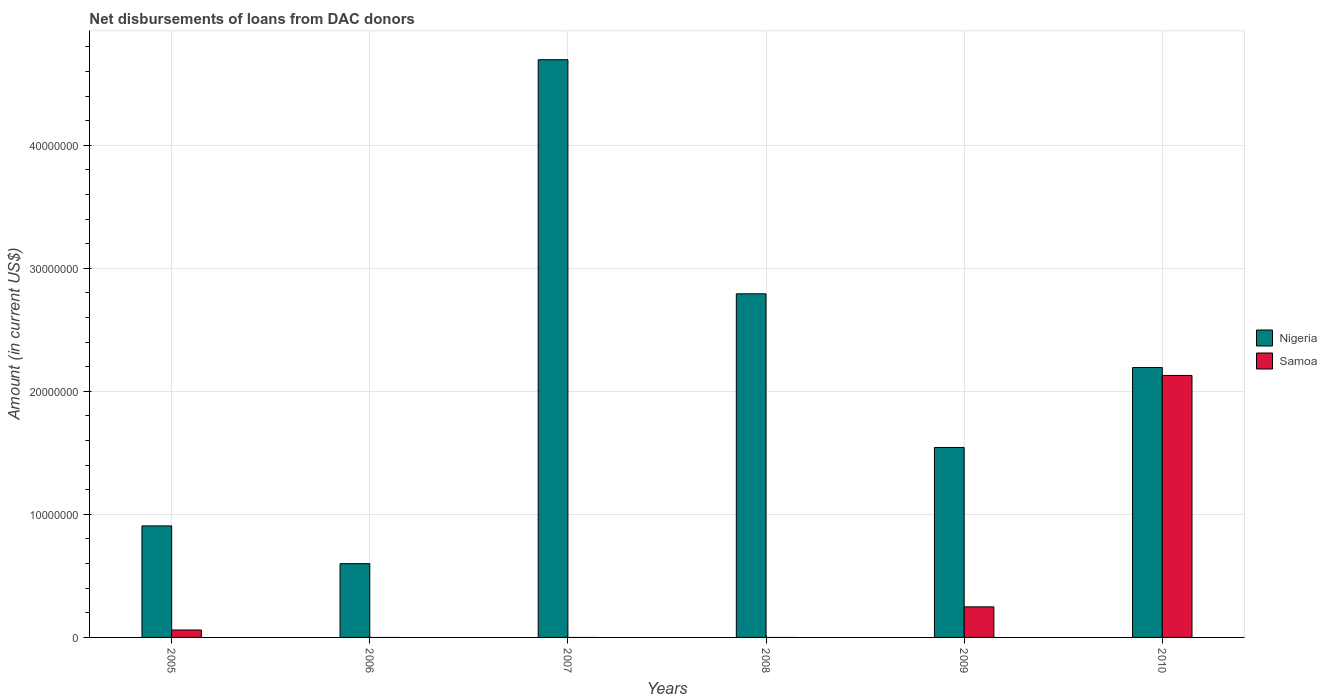How many different coloured bars are there?
Offer a terse response. 2. Are the number of bars per tick equal to the number of legend labels?
Your answer should be very brief. No. How many bars are there on the 5th tick from the right?
Your answer should be very brief. 1. What is the label of the 4th group of bars from the left?
Your answer should be very brief. 2008. What is the amount of loans disbursed in Samoa in 2009?
Your response must be concise. 2.48e+06. Across all years, what is the maximum amount of loans disbursed in Samoa?
Your answer should be very brief. 2.13e+07. Across all years, what is the minimum amount of loans disbursed in Samoa?
Your answer should be compact. 0. What is the total amount of loans disbursed in Samoa in the graph?
Provide a short and direct response. 2.44e+07. What is the difference between the amount of loans disbursed in Nigeria in 2007 and that in 2008?
Your answer should be compact. 1.90e+07. What is the difference between the amount of loans disbursed in Nigeria in 2008 and the amount of loans disbursed in Samoa in 2005?
Offer a very short reply. 2.73e+07. What is the average amount of loans disbursed in Samoa per year?
Your answer should be very brief. 4.06e+06. In the year 2005, what is the difference between the amount of loans disbursed in Samoa and amount of loans disbursed in Nigeria?
Offer a very short reply. -8.46e+06. What is the ratio of the amount of loans disbursed in Samoa in 2009 to that in 2010?
Ensure brevity in your answer.  0.12. Is the amount of loans disbursed in Nigeria in 2007 less than that in 2008?
Make the answer very short. No. What is the difference between the highest and the second highest amount of loans disbursed in Samoa?
Provide a succinct answer. 1.88e+07. What is the difference between the highest and the lowest amount of loans disbursed in Nigeria?
Keep it short and to the point. 4.10e+07. Are all the bars in the graph horizontal?
Provide a short and direct response. No. How many years are there in the graph?
Provide a short and direct response. 6. Does the graph contain any zero values?
Your answer should be very brief. Yes. Does the graph contain grids?
Ensure brevity in your answer.  Yes. Where does the legend appear in the graph?
Offer a terse response. Center right. How many legend labels are there?
Offer a terse response. 2. How are the legend labels stacked?
Provide a short and direct response. Vertical. What is the title of the graph?
Keep it short and to the point. Net disbursements of loans from DAC donors. Does "United States" appear as one of the legend labels in the graph?
Keep it short and to the point. No. What is the label or title of the X-axis?
Provide a succinct answer. Years. What is the Amount (in current US$) in Nigeria in 2005?
Keep it short and to the point. 9.06e+06. What is the Amount (in current US$) of Samoa in 2005?
Provide a short and direct response. 6.04e+05. What is the Amount (in current US$) of Nigeria in 2006?
Keep it short and to the point. 6.00e+06. What is the Amount (in current US$) in Nigeria in 2007?
Keep it short and to the point. 4.70e+07. What is the Amount (in current US$) in Nigeria in 2008?
Keep it short and to the point. 2.79e+07. What is the Amount (in current US$) of Samoa in 2008?
Provide a short and direct response. 0. What is the Amount (in current US$) in Nigeria in 2009?
Ensure brevity in your answer.  1.54e+07. What is the Amount (in current US$) in Samoa in 2009?
Provide a succinct answer. 2.48e+06. What is the Amount (in current US$) in Nigeria in 2010?
Provide a succinct answer. 2.19e+07. What is the Amount (in current US$) of Samoa in 2010?
Keep it short and to the point. 2.13e+07. Across all years, what is the maximum Amount (in current US$) of Nigeria?
Offer a very short reply. 4.70e+07. Across all years, what is the maximum Amount (in current US$) of Samoa?
Your answer should be very brief. 2.13e+07. Across all years, what is the minimum Amount (in current US$) of Nigeria?
Make the answer very short. 6.00e+06. What is the total Amount (in current US$) of Nigeria in the graph?
Provide a succinct answer. 1.27e+08. What is the total Amount (in current US$) of Samoa in the graph?
Keep it short and to the point. 2.44e+07. What is the difference between the Amount (in current US$) of Nigeria in 2005 and that in 2006?
Provide a succinct answer. 3.07e+06. What is the difference between the Amount (in current US$) of Nigeria in 2005 and that in 2007?
Provide a succinct answer. -3.79e+07. What is the difference between the Amount (in current US$) in Nigeria in 2005 and that in 2008?
Ensure brevity in your answer.  -1.89e+07. What is the difference between the Amount (in current US$) in Nigeria in 2005 and that in 2009?
Offer a very short reply. -6.38e+06. What is the difference between the Amount (in current US$) in Samoa in 2005 and that in 2009?
Give a very brief answer. -1.88e+06. What is the difference between the Amount (in current US$) of Nigeria in 2005 and that in 2010?
Offer a very short reply. -1.29e+07. What is the difference between the Amount (in current US$) of Samoa in 2005 and that in 2010?
Offer a terse response. -2.07e+07. What is the difference between the Amount (in current US$) in Nigeria in 2006 and that in 2007?
Provide a short and direct response. -4.10e+07. What is the difference between the Amount (in current US$) in Nigeria in 2006 and that in 2008?
Make the answer very short. -2.19e+07. What is the difference between the Amount (in current US$) in Nigeria in 2006 and that in 2009?
Offer a very short reply. -9.44e+06. What is the difference between the Amount (in current US$) of Nigeria in 2006 and that in 2010?
Ensure brevity in your answer.  -1.59e+07. What is the difference between the Amount (in current US$) of Nigeria in 2007 and that in 2008?
Provide a succinct answer. 1.90e+07. What is the difference between the Amount (in current US$) of Nigeria in 2007 and that in 2009?
Your response must be concise. 3.15e+07. What is the difference between the Amount (in current US$) in Nigeria in 2007 and that in 2010?
Give a very brief answer. 2.50e+07. What is the difference between the Amount (in current US$) of Nigeria in 2008 and that in 2009?
Give a very brief answer. 1.25e+07. What is the difference between the Amount (in current US$) in Nigeria in 2008 and that in 2010?
Provide a short and direct response. 5.99e+06. What is the difference between the Amount (in current US$) of Nigeria in 2009 and that in 2010?
Your answer should be very brief. -6.50e+06. What is the difference between the Amount (in current US$) in Samoa in 2009 and that in 2010?
Your response must be concise. -1.88e+07. What is the difference between the Amount (in current US$) in Nigeria in 2005 and the Amount (in current US$) in Samoa in 2009?
Your answer should be compact. 6.58e+06. What is the difference between the Amount (in current US$) of Nigeria in 2005 and the Amount (in current US$) of Samoa in 2010?
Give a very brief answer. -1.22e+07. What is the difference between the Amount (in current US$) of Nigeria in 2006 and the Amount (in current US$) of Samoa in 2009?
Make the answer very short. 3.51e+06. What is the difference between the Amount (in current US$) of Nigeria in 2006 and the Amount (in current US$) of Samoa in 2010?
Your answer should be very brief. -1.53e+07. What is the difference between the Amount (in current US$) in Nigeria in 2007 and the Amount (in current US$) in Samoa in 2009?
Provide a short and direct response. 4.45e+07. What is the difference between the Amount (in current US$) of Nigeria in 2007 and the Amount (in current US$) of Samoa in 2010?
Your answer should be compact. 2.57e+07. What is the difference between the Amount (in current US$) of Nigeria in 2008 and the Amount (in current US$) of Samoa in 2009?
Offer a very short reply. 2.54e+07. What is the difference between the Amount (in current US$) of Nigeria in 2008 and the Amount (in current US$) of Samoa in 2010?
Offer a very short reply. 6.64e+06. What is the difference between the Amount (in current US$) of Nigeria in 2009 and the Amount (in current US$) of Samoa in 2010?
Your response must be concise. -5.86e+06. What is the average Amount (in current US$) of Nigeria per year?
Give a very brief answer. 2.12e+07. What is the average Amount (in current US$) of Samoa per year?
Make the answer very short. 4.06e+06. In the year 2005, what is the difference between the Amount (in current US$) in Nigeria and Amount (in current US$) in Samoa?
Give a very brief answer. 8.46e+06. In the year 2009, what is the difference between the Amount (in current US$) in Nigeria and Amount (in current US$) in Samoa?
Offer a very short reply. 1.30e+07. In the year 2010, what is the difference between the Amount (in current US$) in Nigeria and Amount (in current US$) in Samoa?
Offer a very short reply. 6.41e+05. What is the ratio of the Amount (in current US$) in Nigeria in 2005 to that in 2006?
Offer a very short reply. 1.51. What is the ratio of the Amount (in current US$) in Nigeria in 2005 to that in 2007?
Your response must be concise. 0.19. What is the ratio of the Amount (in current US$) of Nigeria in 2005 to that in 2008?
Keep it short and to the point. 0.32. What is the ratio of the Amount (in current US$) of Nigeria in 2005 to that in 2009?
Give a very brief answer. 0.59. What is the ratio of the Amount (in current US$) of Samoa in 2005 to that in 2009?
Keep it short and to the point. 0.24. What is the ratio of the Amount (in current US$) in Nigeria in 2005 to that in 2010?
Keep it short and to the point. 0.41. What is the ratio of the Amount (in current US$) of Samoa in 2005 to that in 2010?
Give a very brief answer. 0.03. What is the ratio of the Amount (in current US$) in Nigeria in 2006 to that in 2007?
Ensure brevity in your answer.  0.13. What is the ratio of the Amount (in current US$) of Nigeria in 2006 to that in 2008?
Ensure brevity in your answer.  0.21. What is the ratio of the Amount (in current US$) in Nigeria in 2006 to that in 2009?
Offer a very short reply. 0.39. What is the ratio of the Amount (in current US$) of Nigeria in 2006 to that in 2010?
Your response must be concise. 0.27. What is the ratio of the Amount (in current US$) in Nigeria in 2007 to that in 2008?
Give a very brief answer. 1.68. What is the ratio of the Amount (in current US$) in Nigeria in 2007 to that in 2009?
Offer a terse response. 3.04. What is the ratio of the Amount (in current US$) of Nigeria in 2007 to that in 2010?
Provide a succinct answer. 2.14. What is the ratio of the Amount (in current US$) of Nigeria in 2008 to that in 2009?
Offer a very short reply. 1.81. What is the ratio of the Amount (in current US$) in Nigeria in 2008 to that in 2010?
Give a very brief answer. 1.27. What is the ratio of the Amount (in current US$) in Nigeria in 2009 to that in 2010?
Provide a succinct answer. 0.7. What is the ratio of the Amount (in current US$) in Samoa in 2009 to that in 2010?
Offer a very short reply. 0.12. What is the difference between the highest and the second highest Amount (in current US$) in Nigeria?
Keep it short and to the point. 1.90e+07. What is the difference between the highest and the second highest Amount (in current US$) of Samoa?
Offer a terse response. 1.88e+07. What is the difference between the highest and the lowest Amount (in current US$) in Nigeria?
Make the answer very short. 4.10e+07. What is the difference between the highest and the lowest Amount (in current US$) in Samoa?
Your response must be concise. 2.13e+07. 